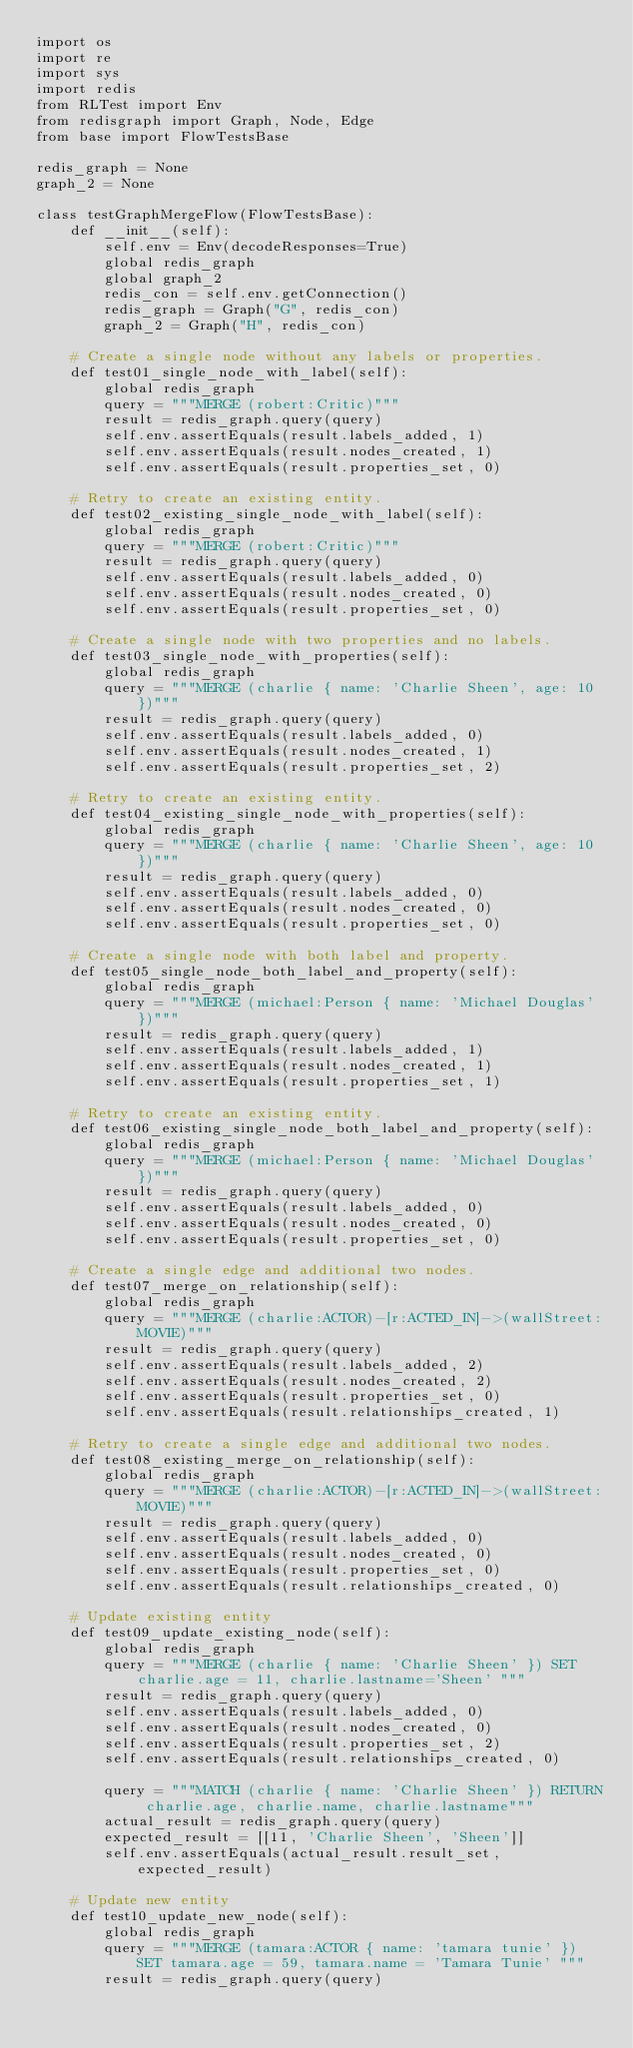<code> <loc_0><loc_0><loc_500><loc_500><_Python_>import os
import re
import sys
import redis
from RLTest import Env
from redisgraph import Graph, Node, Edge
from base import FlowTestsBase

redis_graph = None
graph_2 = None

class testGraphMergeFlow(FlowTestsBase):
    def __init__(self):
        self.env = Env(decodeResponses=True)
        global redis_graph
        global graph_2
        redis_con = self.env.getConnection()
        redis_graph = Graph("G", redis_con)
        graph_2 = Graph("H", redis_con)

    # Create a single node without any labels or properties.
    def test01_single_node_with_label(self):
        global redis_graph
        query = """MERGE (robert:Critic)"""
        result = redis_graph.query(query)
        self.env.assertEquals(result.labels_added, 1)
        self.env.assertEquals(result.nodes_created, 1)
        self.env.assertEquals(result.properties_set, 0)

    # Retry to create an existing entity.
    def test02_existing_single_node_with_label(self):
        global redis_graph
        query = """MERGE (robert:Critic)"""
        result = redis_graph.query(query)
        self.env.assertEquals(result.labels_added, 0)
        self.env.assertEquals(result.nodes_created, 0)
        self.env.assertEquals(result.properties_set, 0)

    # Create a single node with two properties and no labels.
    def test03_single_node_with_properties(self):
        global redis_graph
        query = """MERGE (charlie { name: 'Charlie Sheen', age: 10 })"""
        result = redis_graph.query(query)
        self.env.assertEquals(result.labels_added, 0)
        self.env.assertEquals(result.nodes_created, 1)
        self.env.assertEquals(result.properties_set, 2)

    # Retry to create an existing entity.
    def test04_existing_single_node_with_properties(self):
        global redis_graph
        query = """MERGE (charlie { name: 'Charlie Sheen', age: 10 })"""
        result = redis_graph.query(query)
        self.env.assertEquals(result.labels_added, 0)
        self.env.assertEquals(result.nodes_created, 0)
        self.env.assertEquals(result.properties_set, 0)

    # Create a single node with both label and property.
    def test05_single_node_both_label_and_property(self):
        global redis_graph
        query = """MERGE (michael:Person { name: 'Michael Douglas' })"""
        result = redis_graph.query(query)
        self.env.assertEquals(result.labels_added, 1)
        self.env.assertEquals(result.nodes_created, 1)
        self.env.assertEquals(result.properties_set, 1)

    # Retry to create an existing entity.
    def test06_existing_single_node_both_label_and_property(self):
        global redis_graph
        query = """MERGE (michael:Person { name: 'Michael Douglas' })"""
        result = redis_graph.query(query)
        self.env.assertEquals(result.labels_added, 0)
        self.env.assertEquals(result.nodes_created, 0)
        self.env.assertEquals(result.properties_set, 0)

    # Create a single edge and additional two nodes.
    def test07_merge_on_relationship(self):
        global redis_graph
        query = """MERGE (charlie:ACTOR)-[r:ACTED_IN]->(wallStreet:MOVIE)"""
        result = redis_graph.query(query)
        self.env.assertEquals(result.labels_added, 2)
        self.env.assertEquals(result.nodes_created, 2)
        self.env.assertEquals(result.properties_set, 0)
        self.env.assertEquals(result.relationships_created, 1)

    # Retry to create a single edge and additional two nodes.
    def test08_existing_merge_on_relationship(self):
        global redis_graph
        query = """MERGE (charlie:ACTOR)-[r:ACTED_IN]->(wallStreet:MOVIE)"""
        result = redis_graph.query(query)
        self.env.assertEquals(result.labels_added, 0)
        self.env.assertEquals(result.nodes_created, 0)
        self.env.assertEquals(result.properties_set, 0)
        self.env.assertEquals(result.relationships_created, 0)

    # Update existing entity
    def test09_update_existing_node(self):
        global redis_graph
        query = """MERGE (charlie { name: 'Charlie Sheen' }) SET charlie.age = 11, charlie.lastname='Sheen' """
        result = redis_graph.query(query)
        self.env.assertEquals(result.labels_added, 0)
        self.env.assertEquals(result.nodes_created, 0)
        self.env.assertEquals(result.properties_set, 2)
        self.env.assertEquals(result.relationships_created, 0)

        query = """MATCH (charlie { name: 'Charlie Sheen' }) RETURN charlie.age, charlie.name, charlie.lastname"""
        actual_result = redis_graph.query(query)
        expected_result = [[11, 'Charlie Sheen', 'Sheen']]
        self.env.assertEquals(actual_result.result_set, expected_result)

    # Update new entity
    def test10_update_new_node(self):
        global redis_graph
        query = """MERGE (tamara:ACTOR { name: 'tamara tunie' }) SET tamara.age = 59, tamara.name = 'Tamara Tunie' """
        result = redis_graph.query(query)</code> 